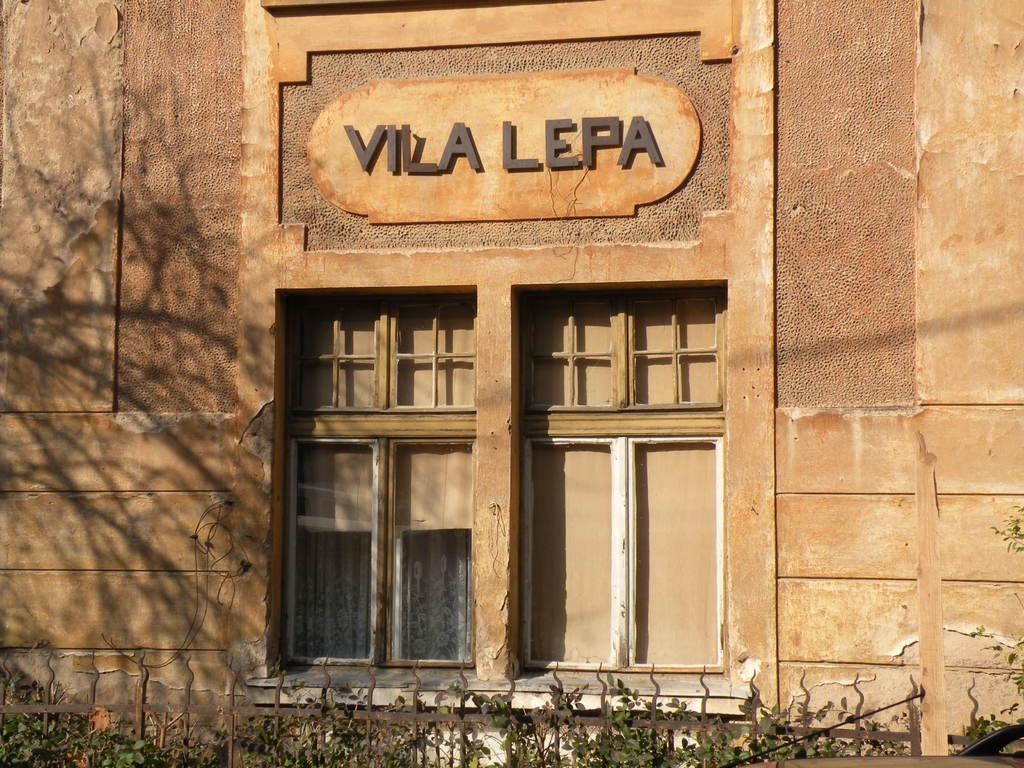What type of structure is visible in the image? There is a building in the image. What feature can be seen on the building? The building has windows. Is there any text or label on the building? Yes, there is a name written on the building. What is located in front of the building? There are plants in front of the building. What season is depicted in the image, considering the presence of spring flowers? There is no mention of spring flowers or any specific season in the image; it only shows a building with windows and a name, as well as plants in front of it. 